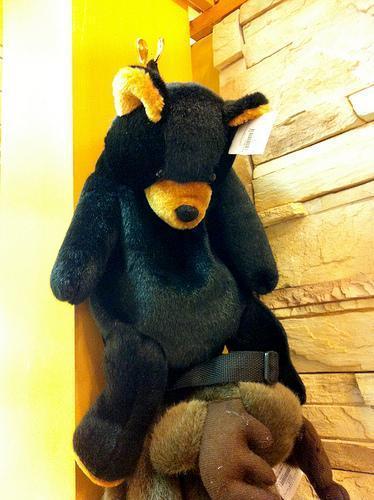How many bears are there?
Give a very brief answer. 1. 